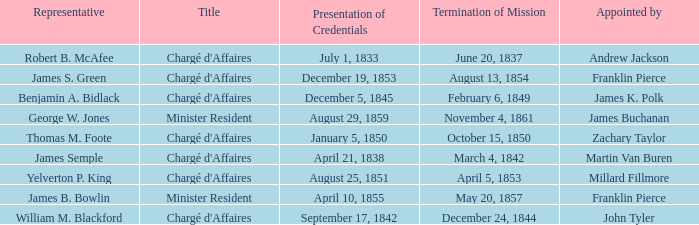What Title has a Termination of Mission of November 4, 1861? Minister Resident. 